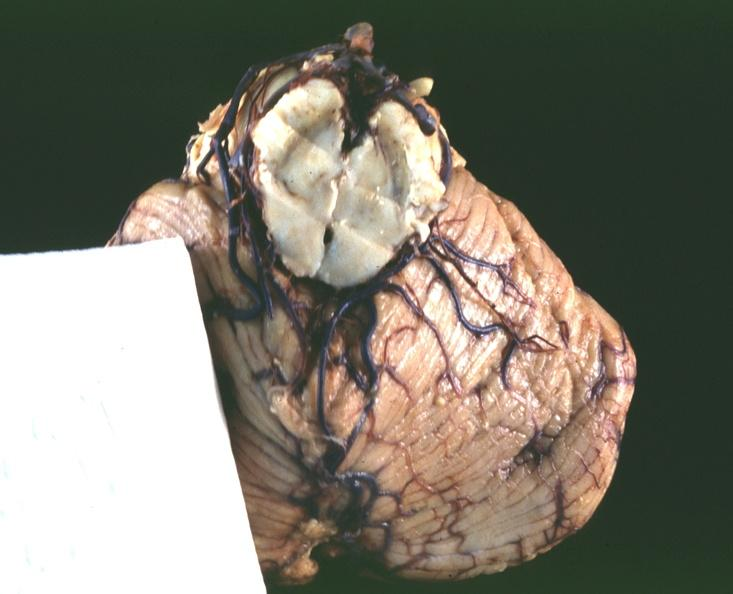what is present?
Answer the question using a single word or phrase. Nervous 